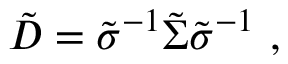Convert formula to latex. <formula><loc_0><loc_0><loc_500><loc_500>\tilde { D } = \tilde { \sigma } ^ { - 1 } \tilde { \Sigma } \tilde { \sigma } ^ { - 1 } \ ,</formula> 